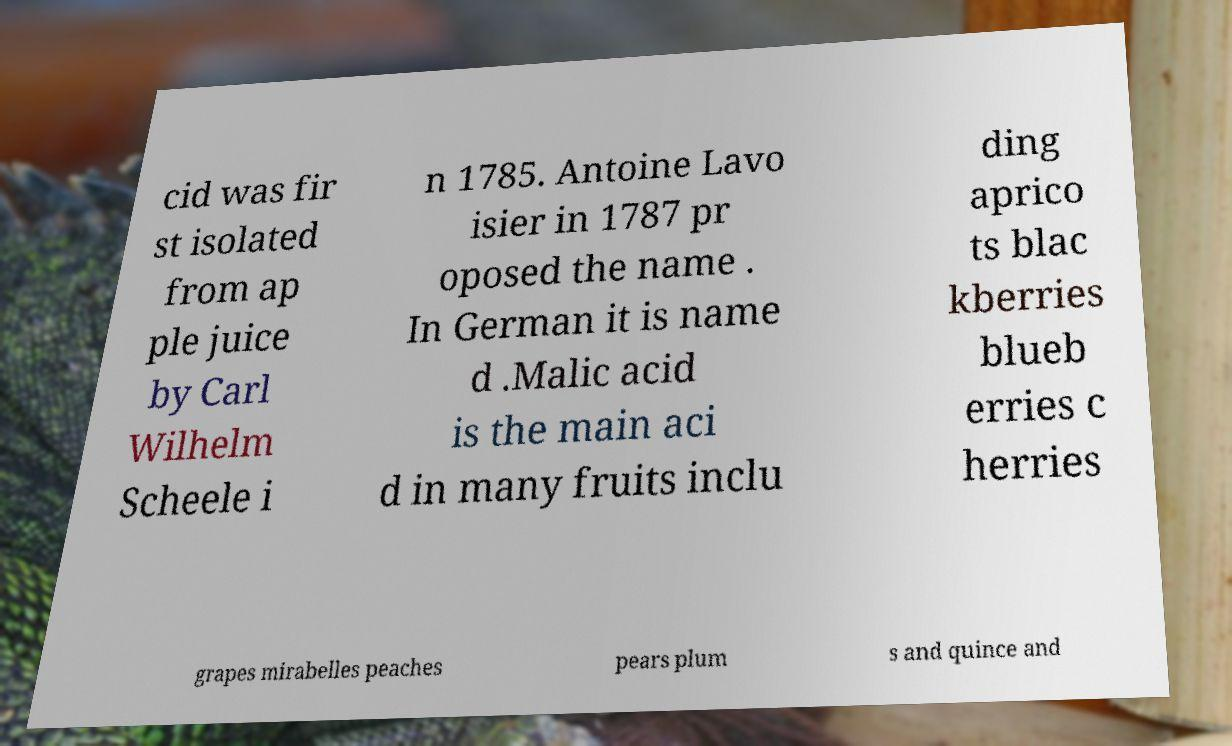For documentation purposes, I need the text within this image transcribed. Could you provide that? cid was fir st isolated from ap ple juice by Carl Wilhelm Scheele i n 1785. Antoine Lavo isier in 1787 pr oposed the name . In German it is name d .Malic acid is the main aci d in many fruits inclu ding aprico ts blac kberries blueb erries c herries grapes mirabelles peaches pears plum s and quince and 